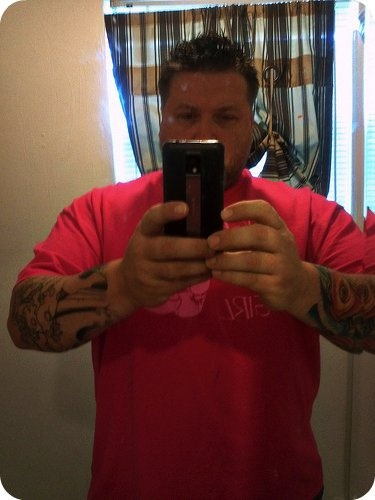Describe the objects in this image and their specific colors. I can see people in white, maroon, black, and brown tones and cell phone in white, black, maroon, and gray tones in this image. 